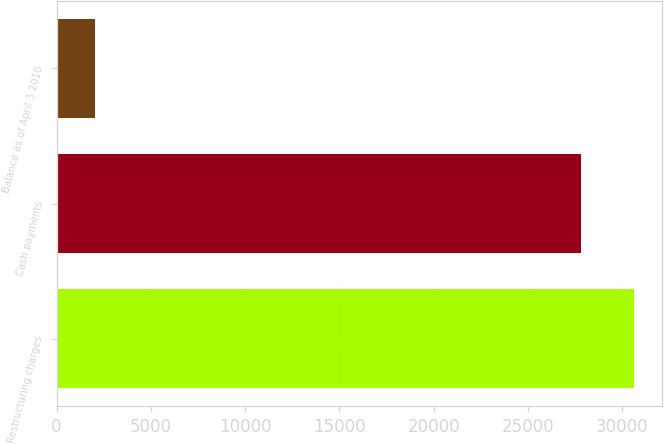Convert chart. <chart><loc_0><loc_0><loc_500><loc_500><bar_chart><fcel>Restructuring charges<fcel>Cash payments<fcel>Balance as of April 3 2010<nl><fcel>30593.1<fcel>27788<fcel>2013<nl></chart> 